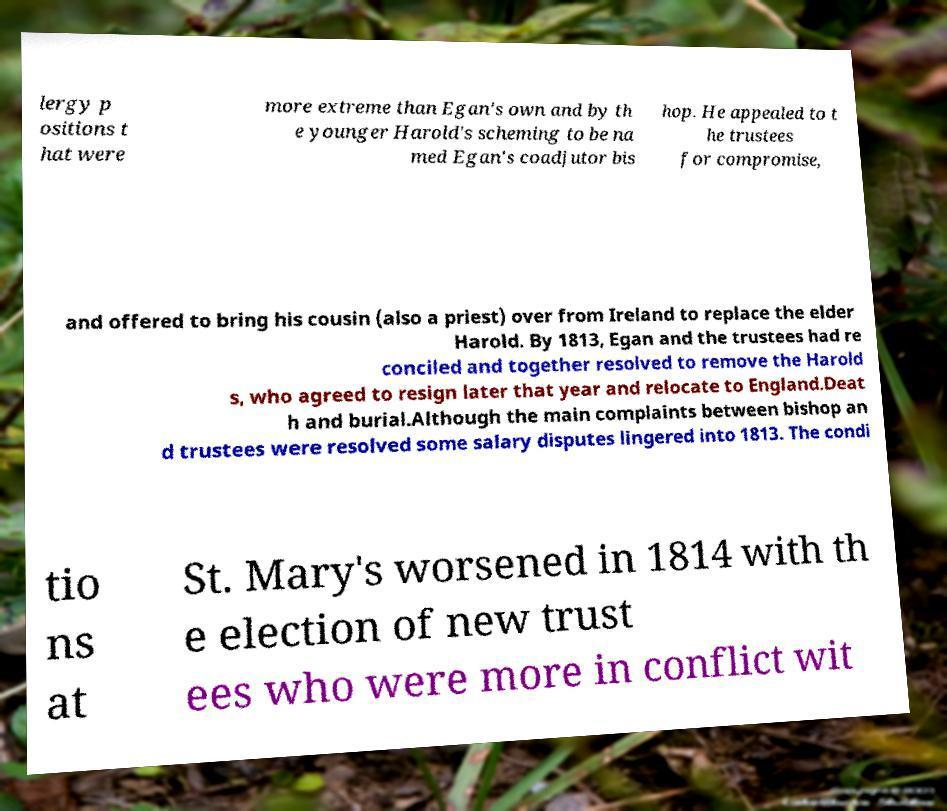What messages or text are displayed in this image? I need them in a readable, typed format. lergy p ositions t hat were more extreme than Egan's own and by th e younger Harold's scheming to be na med Egan's coadjutor bis hop. He appealed to t he trustees for compromise, and offered to bring his cousin (also a priest) over from Ireland to replace the elder Harold. By 1813, Egan and the trustees had re conciled and together resolved to remove the Harold s, who agreed to resign later that year and relocate to England.Deat h and burial.Although the main complaints between bishop an d trustees were resolved some salary disputes lingered into 1813. The condi tio ns at St. Mary's worsened in 1814 with th e election of new trust ees who were more in conflict wit 